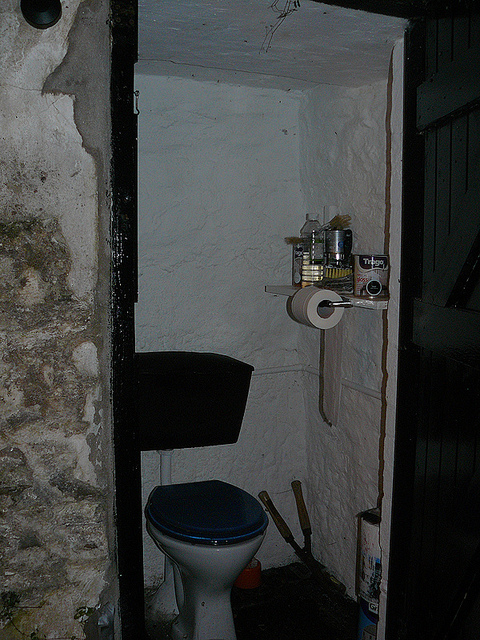<image>Is the toilet paper coming over the top or from the bottom? I am not sure if the toilet paper is coming over the top or from the bottom. Is the toilet paper coming over the top or from the bottom? I don't know if the toilet paper is coming over the top or from the bottom. It can be seen both ways. 